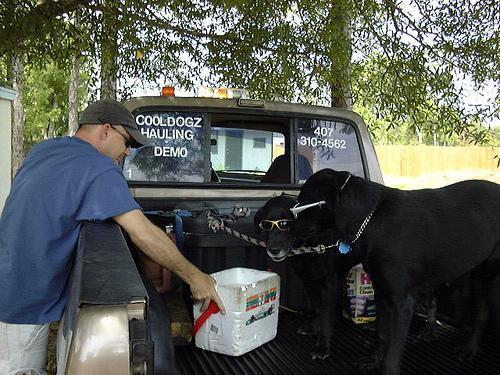How many windows on the back of the truck's cab have numbers on it?
Give a very brief answer. 1. 